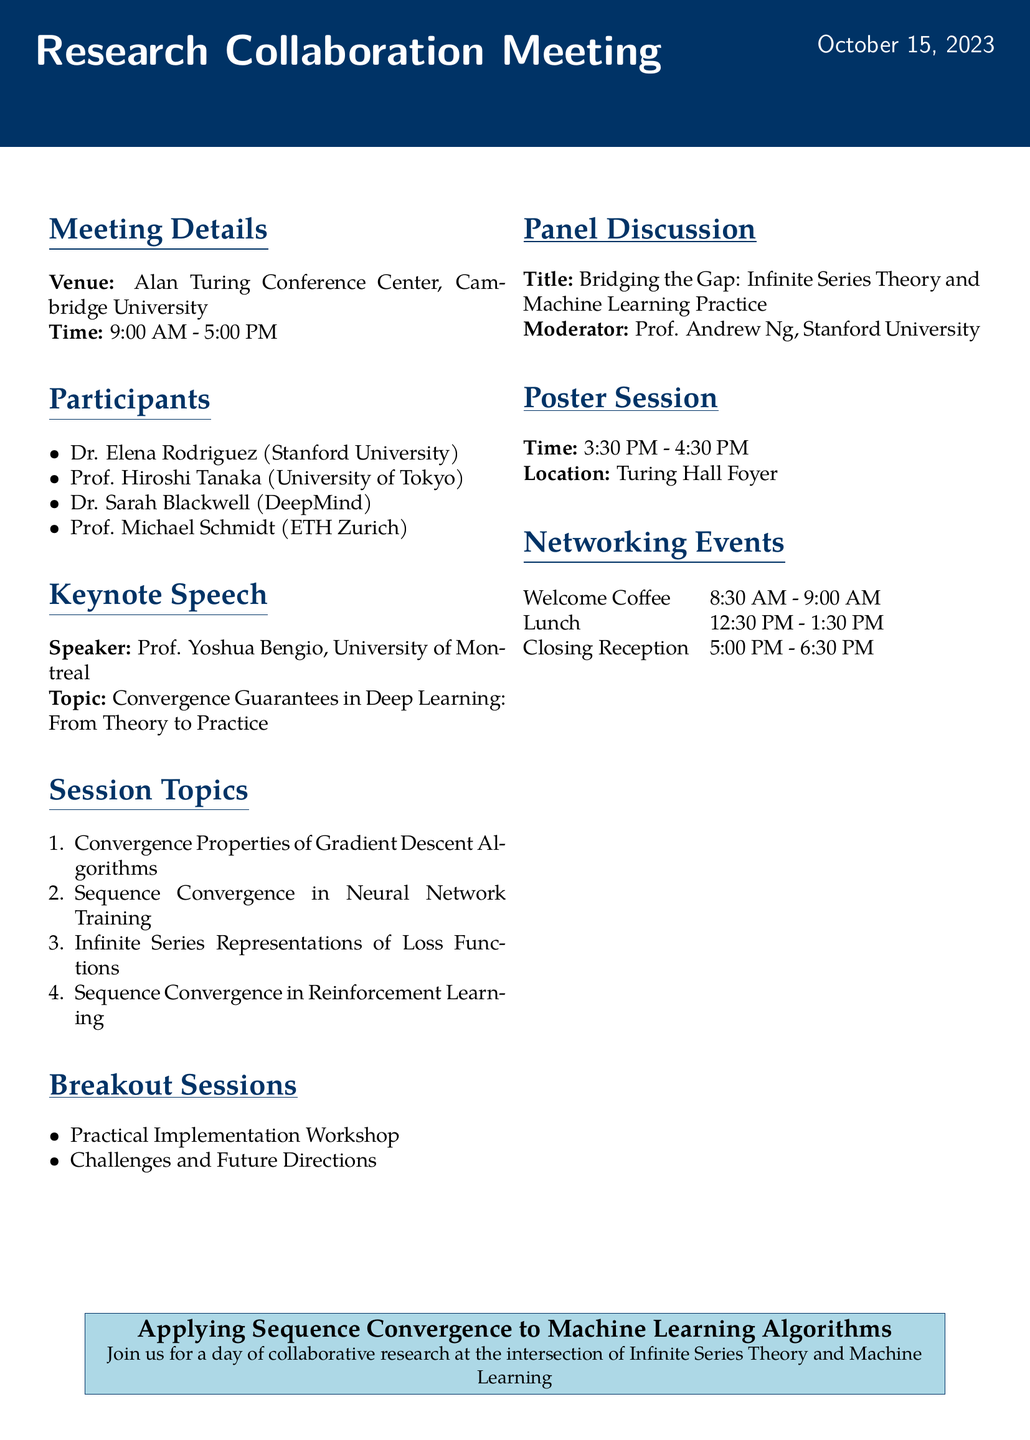What is the title of the meeting? The title of the meeting is specified in the document as part of the meeting details.
Answer: Research Collaboration Meeting: Applying Sequence Convergence to Machine Learning Algorithms Who is the keynote speaker? The keynote speaker is listed in the keynote speech section of the document.
Answer: Prof. Yoshua Bengio What is the venue of the meeting? The venue is provided in the meeting details section of the document.
Answer: Alan Turing Conference Center, Cambridge University What time does the poster session start? The time for the poster session is mentioned under the poster session section.
Answer: 3:30 PM Which breakout session focuses on practical implementation? The breakout sessions are specified in their respective section, indicating the focus areas.
Answer: Practical Implementation Workshop How many session topics are listed? The number of session topics can be counted from the session topics section in the document.
Answer: Four Who is the moderator of the panel discussion? The name of the moderator is detailed under the panel discussion section.
Answer: Prof. Andrew Ng What time does the closing reception end? The closing reception's time is mentioned in the networking events section of the document.
Answer: 6:30 PM What is discussed in the poster session themes? The themes for the poster session offer insight into the topics presented, available in the poster session section.
Answer: Novel convergence proofs for ML algorithms, Visualization tools for sequence behavior in neural networks, Applications of sequence convergence in specific ML domains 